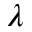Convert formula to latex. <formula><loc_0><loc_0><loc_500><loc_500>\lambda</formula> 